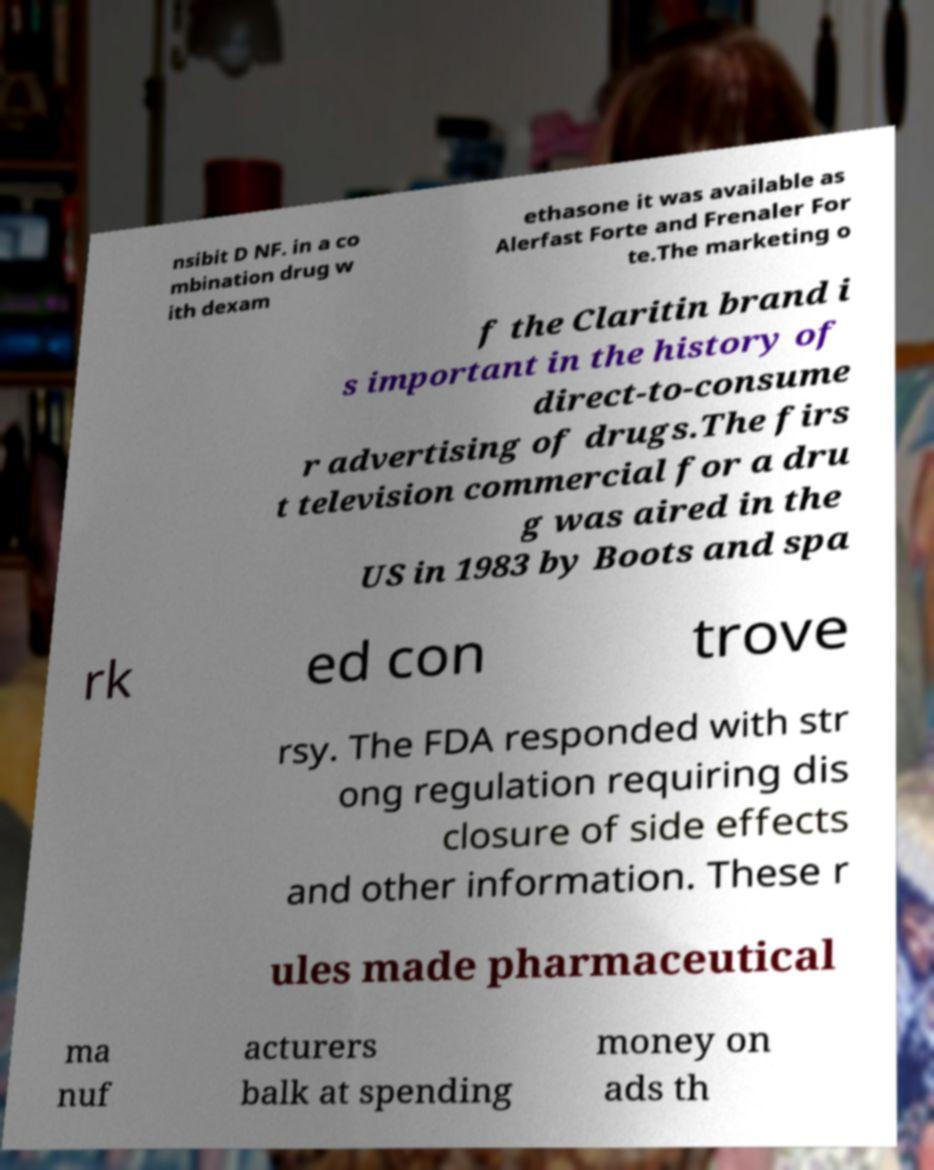Can you read and provide the text displayed in the image?This photo seems to have some interesting text. Can you extract and type it out for me? nsibit D NF. in a co mbination drug w ith dexam ethasone it was available as Alerfast Forte and Frenaler For te.The marketing o f the Claritin brand i s important in the history of direct-to-consume r advertising of drugs.The firs t television commercial for a dru g was aired in the US in 1983 by Boots and spa rk ed con trove rsy. The FDA responded with str ong regulation requiring dis closure of side effects and other information. These r ules made pharmaceutical ma nuf acturers balk at spending money on ads th 